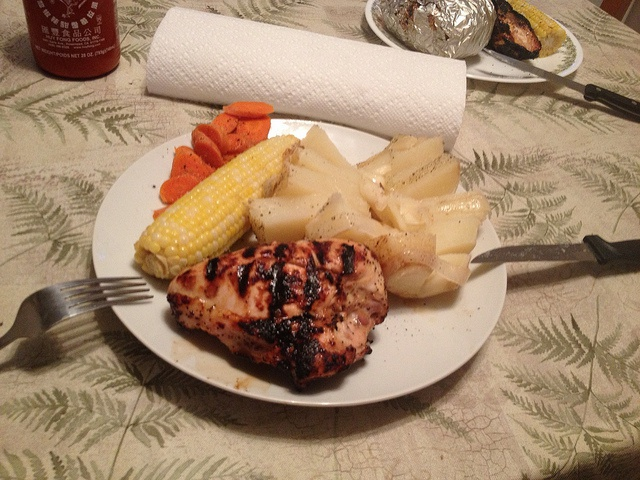Describe the objects in this image and their specific colors. I can see dining table in tan, gray, and black tones, bottle in gray, maroon, and brown tones, fork in gray, black, and maroon tones, carrot in tan, red, and brown tones, and knife in gray, maroon, and black tones in this image. 